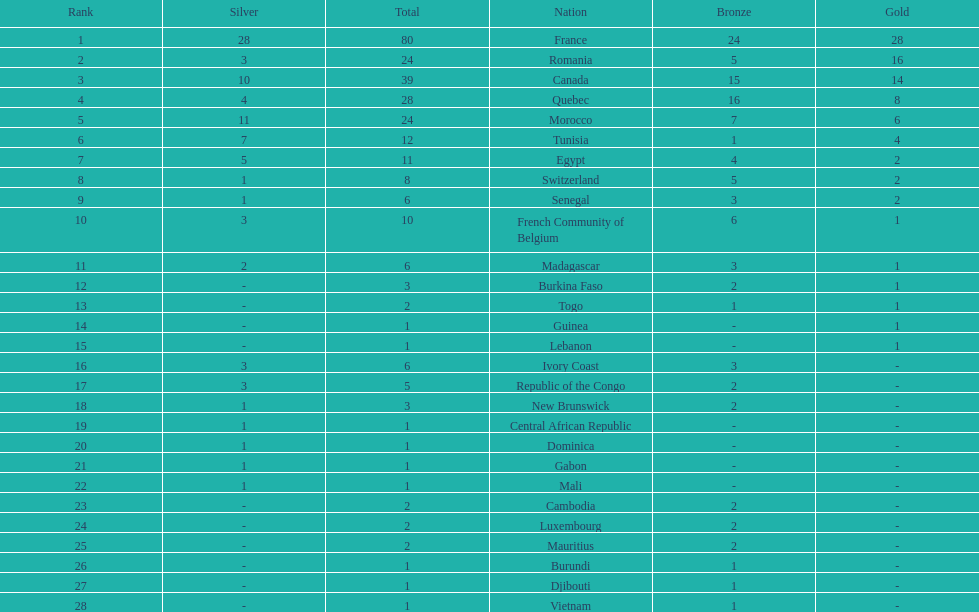How many bronze medals does togo have? 1. Could you help me parse every detail presented in this table? {'header': ['Rank', 'Silver', 'Total', 'Nation', 'Bronze', 'Gold'], 'rows': [['1', '28', '80', 'France', '24', '28'], ['2', '3', '24', 'Romania', '5', '16'], ['3', '10', '39', 'Canada', '15', '14'], ['4', '4', '28', 'Quebec', '16', '8'], ['5', '11', '24', 'Morocco', '7', '6'], ['6', '7', '12', 'Tunisia', '1', '4'], ['7', '5', '11', 'Egypt', '4', '2'], ['8', '1', '8', 'Switzerland', '5', '2'], ['9', '1', '6', 'Senegal', '3', '2'], ['10', '3', '10', 'French Community of Belgium', '6', '1'], ['11', '2', '6', 'Madagascar', '3', '1'], ['12', '-', '3', 'Burkina Faso', '2', '1'], ['13', '-', '2', 'Togo', '1', '1'], ['14', '-', '1', 'Guinea', '-', '1'], ['15', '-', '1', 'Lebanon', '-', '1'], ['16', '3', '6', 'Ivory Coast', '3', '-'], ['17', '3', '5', 'Republic of the Congo', '2', '-'], ['18', '1', '3', 'New Brunswick', '2', '-'], ['19', '1', '1', 'Central African Republic', '-', '-'], ['20', '1', '1', 'Dominica', '-', '-'], ['21', '1', '1', 'Gabon', '-', '-'], ['22', '1', '1', 'Mali', '-', '-'], ['23', '-', '2', 'Cambodia', '2', '-'], ['24', '-', '2', 'Luxembourg', '2', '-'], ['25', '-', '2', 'Mauritius', '2', '-'], ['26', '-', '1', 'Burundi', '1', '-'], ['27', '-', '1', 'Djibouti', '1', '-'], ['28', '-', '1', 'Vietnam', '1', '-']]} 